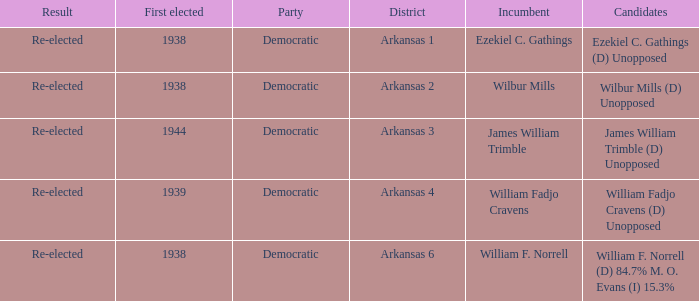How many districts had William F. Norrell as the incumbent? 1.0. 